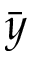<formula> <loc_0><loc_0><loc_500><loc_500>\bar { y }</formula> 